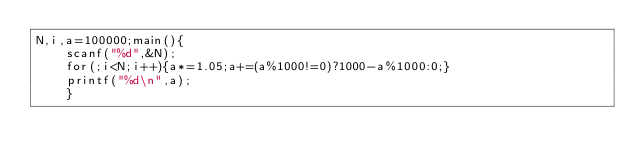<code> <loc_0><loc_0><loc_500><loc_500><_C_>N,i,a=100000;main(){
	scanf("%d",&N);
	for(;i<N;i++){a*=1.05;a+=(a%1000!=0)?1000-a%1000:0;}
	printf("%d\n",a);
	}</code> 